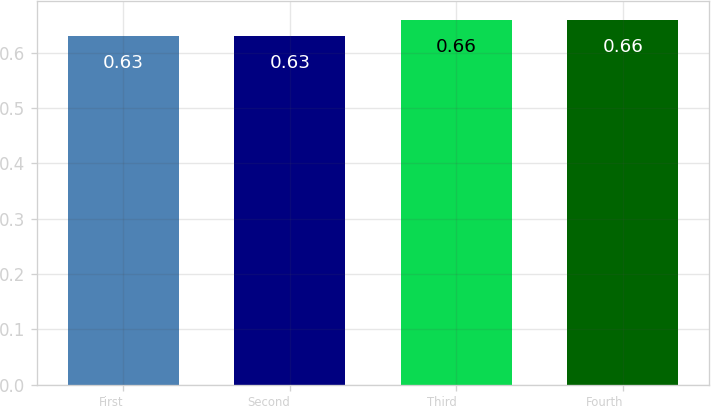Convert chart to OTSL. <chart><loc_0><loc_0><loc_500><loc_500><bar_chart><fcel>First<fcel>Second<fcel>Third<fcel>Fourth<nl><fcel>0.63<fcel>0.63<fcel>0.66<fcel>0.66<nl></chart> 